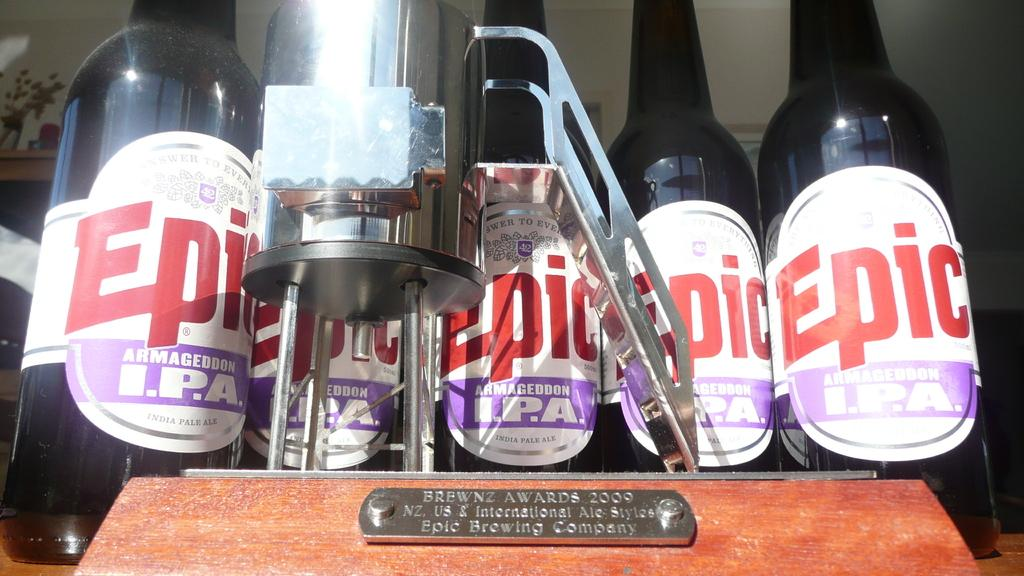Provide a one-sentence caption for the provided image. four bottles lined up  across a shelf that the bottle say epic and they are in front of a magnifier glass. 